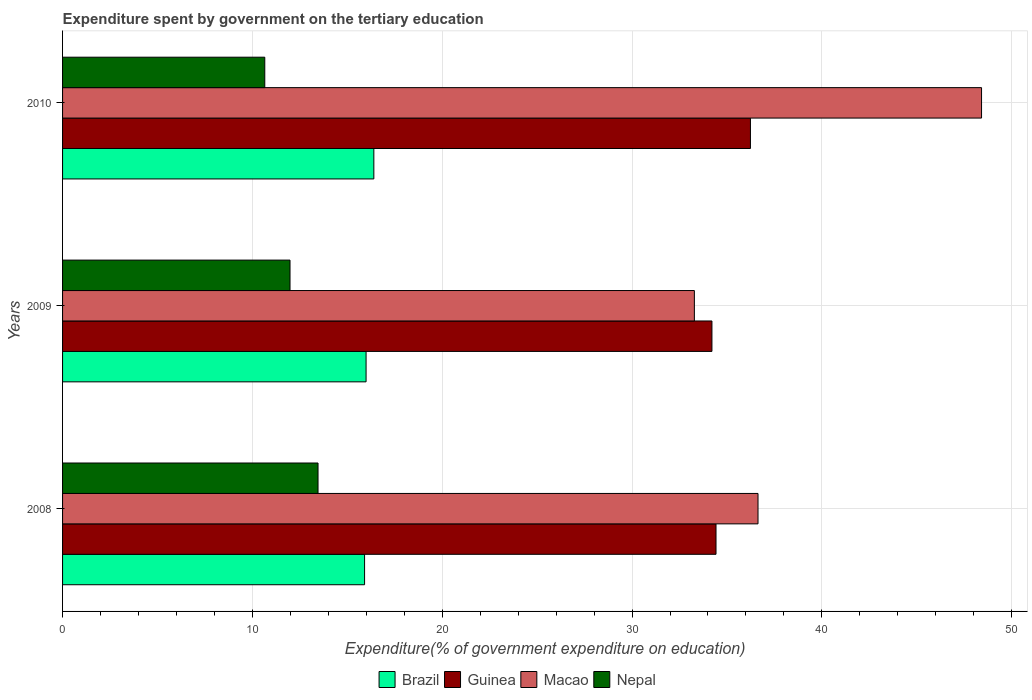How many groups of bars are there?
Provide a short and direct response. 3. Are the number of bars on each tick of the Y-axis equal?
Ensure brevity in your answer.  Yes. In how many cases, is the number of bars for a given year not equal to the number of legend labels?
Ensure brevity in your answer.  0. What is the expenditure spent by government on the tertiary education in Macao in 2010?
Offer a terse response. 48.41. Across all years, what is the maximum expenditure spent by government on the tertiary education in Nepal?
Keep it short and to the point. 13.46. Across all years, what is the minimum expenditure spent by government on the tertiary education in Nepal?
Keep it short and to the point. 10.65. In which year was the expenditure spent by government on the tertiary education in Macao maximum?
Make the answer very short. 2010. In which year was the expenditure spent by government on the tertiary education in Brazil minimum?
Keep it short and to the point. 2008. What is the total expenditure spent by government on the tertiary education in Macao in the graph?
Your answer should be very brief. 118.33. What is the difference between the expenditure spent by government on the tertiary education in Guinea in 2008 and that in 2010?
Make the answer very short. -1.81. What is the difference between the expenditure spent by government on the tertiary education in Nepal in 2010 and the expenditure spent by government on the tertiary education in Brazil in 2009?
Offer a terse response. -5.34. What is the average expenditure spent by government on the tertiary education in Brazil per year?
Your response must be concise. 16.1. In the year 2008, what is the difference between the expenditure spent by government on the tertiary education in Brazil and expenditure spent by government on the tertiary education in Guinea?
Your answer should be very brief. -18.51. In how many years, is the expenditure spent by government on the tertiary education in Guinea greater than 24 %?
Your answer should be compact. 3. What is the ratio of the expenditure spent by government on the tertiary education in Macao in 2008 to that in 2009?
Provide a succinct answer. 1.1. Is the expenditure spent by government on the tertiary education in Brazil in 2009 less than that in 2010?
Give a very brief answer. Yes. What is the difference between the highest and the second highest expenditure spent by government on the tertiary education in Macao?
Offer a terse response. 11.78. What is the difference between the highest and the lowest expenditure spent by government on the tertiary education in Brazil?
Your answer should be very brief. 0.49. In how many years, is the expenditure spent by government on the tertiary education in Macao greater than the average expenditure spent by government on the tertiary education in Macao taken over all years?
Your answer should be compact. 1. Is it the case that in every year, the sum of the expenditure spent by government on the tertiary education in Guinea and expenditure spent by government on the tertiary education in Macao is greater than the sum of expenditure spent by government on the tertiary education in Brazil and expenditure spent by government on the tertiary education in Nepal?
Ensure brevity in your answer.  No. What does the 1st bar from the top in 2009 represents?
Offer a terse response. Nepal. What does the 2nd bar from the bottom in 2009 represents?
Ensure brevity in your answer.  Guinea. What is the difference between two consecutive major ticks on the X-axis?
Ensure brevity in your answer.  10. Are the values on the major ticks of X-axis written in scientific E-notation?
Offer a terse response. No. Does the graph contain any zero values?
Keep it short and to the point. No. Where does the legend appear in the graph?
Your answer should be compact. Bottom center. What is the title of the graph?
Ensure brevity in your answer.  Expenditure spent by government on the tertiary education. Does "Portugal" appear as one of the legend labels in the graph?
Keep it short and to the point. No. What is the label or title of the X-axis?
Offer a very short reply. Expenditure(% of government expenditure on education). What is the Expenditure(% of government expenditure on education) of Brazil in 2008?
Make the answer very short. 15.91. What is the Expenditure(% of government expenditure on education) of Guinea in 2008?
Make the answer very short. 34.42. What is the Expenditure(% of government expenditure on education) in Macao in 2008?
Give a very brief answer. 36.64. What is the Expenditure(% of government expenditure on education) of Nepal in 2008?
Offer a very short reply. 13.46. What is the Expenditure(% of government expenditure on education) in Brazil in 2009?
Offer a very short reply. 15.99. What is the Expenditure(% of government expenditure on education) in Guinea in 2009?
Offer a terse response. 34.21. What is the Expenditure(% of government expenditure on education) of Macao in 2009?
Offer a very short reply. 33.28. What is the Expenditure(% of government expenditure on education) in Nepal in 2009?
Your response must be concise. 11.98. What is the Expenditure(% of government expenditure on education) in Brazil in 2010?
Ensure brevity in your answer.  16.4. What is the Expenditure(% of government expenditure on education) in Guinea in 2010?
Your answer should be compact. 36.24. What is the Expenditure(% of government expenditure on education) of Macao in 2010?
Offer a terse response. 48.41. What is the Expenditure(% of government expenditure on education) in Nepal in 2010?
Offer a very short reply. 10.65. Across all years, what is the maximum Expenditure(% of government expenditure on education) of Brazil?
Keep it short and to the point. 16.4. Across all years, what is the maximum Expenditure(% of government expenditure on education) of Guinea?
Offer a terse response. 36.24. Across all years, what is the maximum Expenditure(% of government expenditure on education) in Macao?
Your answer should be compact. 48.41. Across all years, what is the maximum Expenditure(% of government expenditure on education) in Nepal?
Your answer should be very brief. 13.46. Across all years, what is the minimum Expenditure(% of government expenditure on education) in Brazil?
Offer a very short reply. 15.91. Across all years, what is the minimum Expenditure(% of government expenditure on education) in Guinea?
Provide a succinct answer. 34.21. Across all years, what is the minimum Expenditure(% of government expenditure on education) of Macao?
Make the answer very short. 33.28. Across all years, what is the minimum Expenditure(% of government expenditure on education) in Nepal?
Give a very brief answer. 10.65. What is the total Expenditure(% of government expenditure on education) of Brazil in the graph?
Give a very brief answer. 48.3. What is the total Expenditure(% of government expenditure on education) in Guinea in the graph?
Provide a short and direct response. 104.87. What is the total Expenditure(% of government expenditure on education) in Macao in the graph?
Offer a very short reply. 118.33. What is the total Expenditure(% of government expenditure on education) in Nepal in the graph?
Keep it short and to the point. 36.09. What is the difference between the Expenditure(% of government expenditure on education) of Brazil in 2008 and that in 2009?
Offer a very short reply. -0.08. What is the difference between the Expenditure(% of government expenditure on education) in Guinea in 2008 and that in 2009?
Ensure brevity in your answer.  0.22. What is the difference between the Expenditure(% of government expenditure on education) in Macao in 2008 and that in 2009?
Keep it short and to the point. 3.35. What is the difference between the Expenditure(% of government expenditure on education) of Nepal in 2008 and that in 2009?
Offer a very short reply. 1.48. What is the difference between the Expenditure(% of government expenditure on education) of Brazil in 2008 and that in 2010?
Give a very brief answer. -0.49. What is the difference between the Expenditure(% of government expenditure on education) in Guinea in 2008 and that in 2010?
Your response must be concise. -1.81. What is the difference between the Expenditure(% of government expenditure on education) of Macao in 2008 and that in 2010?
Offer a terse response. -11.78. What is the difference between the Expenditure(% of government expenditure on education) in Nepal in 2008 and that in 2010?
Keep it short and to the point. 2.8. What is the difference between the Expenditure(% of government expenditure on education) of Brazil in 2009 and that in 2010?
Make the answer very short. -0.41. What is the difference between the Expenditure(% of government expenditure on education) in Guinea in 2009 and that in 2010?
Give a very brief answer. -2.03. What is the difference between the Expenditure(% of government expenditure on education) of Macao in 2009 and that in 2010?
Your answer should be compact. -15.13. What is the difference between the Expenditure(% of government expenditure on education) in Nepal in 2009 and that in 2010?
Ensure brevity in your answer.  1.33. What is the difference between the Expenditure(% of government expenditure on education) of Brazil in 2008 and the Expenditure(% of government expenditure on education) of Guinea in 2009?
Your answer should be very brief. -18.3. What is the difference between the Expenditure(% of government expenditure on education) in Brazil in 2008 and the Expenditure(% of government expenditure on education) in Macao in 2009?
Offer a terse response. -17.37. What is the difference between the Expenditure(% of government expenditure on education) in Brazil in 2008 and the Expenditure(% of government expenditure on education) in Nepal in 2009?
Make the answer very short. 3.93. What is the difference between the Expenditure(% of government expenditure on education) in Guinea in 2008 and the Expenditure(% of government expenditure on education) in Macao in 2009?
Make the answer very short. 1.14. What is the difference between the Expenditure(% of government expenditure on education) in Guinea in 2008 and the Expenditure(% of government expenditure on education) in Nepal in 2009?
Make the answer very short. 22.44. What is the difference between the Expenditure(% of government expenditure on education) of Macao in 2008 and the Expenditure(% of government expenditure on education) of Nepal in 2009?
Provide a short and direct response. 24.65. What is the difference between the Expenditure(% of government expenditure on education) of Brazil in 2008 and the Expenditure(% of government expenditure on education) of Guinea in 2010?
Provide a succinct answer. -20.33. What is the difference between the Expenditure(% of government expenditure on education) in Brazil in 2008 and the Expenditure(% of government expenditure on education) in Macao in 2010?
Your answer should be compact. -32.5. What is the difference between the Expenditure(% of government expenditure on education) of Brazil in 2008 and the Expenditure(% of government expenditure on education) of Nepal in 2010?
Make the answer very short. 5.26. What is the difference between the Expenditure(% of government expenditure on education) in Guinea in 2008 and the Expenditure(% of government expenditure on education) in Macao in 2010?
Your answer should be compact. -13.99. What is the difference between the Expenditure(% of government expenditure on education) in Guinea in 2008 and the Expenditure(% of government expenditure on education) in Nepal in 2010?
Make the answer very short. 23.77. What is the difference between the Expenditure(% of government expenditure on education) of Macao in 2008 and the Expenditure(% of government expenditure on education) of Nepal in 2010?
Keep it short and to the point. 25.98. What is the difference between the Expenditure(% of government expenditure on education) of Brazil in 2009 and the Expenditure(% of government expenditure on education) of Guinea in 2010?
Make the answer very short. -20.25. What is the difference between the Expenditure(% of government expenditure on education) of Brazil in 2009 and the Expenditure(% of government expenditure on education) of Macao in 2010?
Your response must be concise. -32.42. What is the difference between the Expenditure(% of government expenditure on education) of Brazil in 2009 and the Expenditure(% of government expenditure on education) of Nepal in 2010?
Offer a terse response. 5.34. What is the difference between the Expenditure(% of government expenditure on education) of Guinea in 2009 and the Expenditure(% of government expenditure on education) of Macao in 2010?
Keep it short and to the point. -14.2. What is the difference between the Expenditure(% of government expenditure on education) of Guinea in 2009 and the Expenditure(% of government expenditure on education) of Nepal in 2010?
Offer a terse response. 23.56. What is the difference between the Expenditure(% of government expenditure on education) of Macao in 2009 and the Expenditure(% of government expenditure on education) of Nepal in 2010?
Your answer should be compact. 22.63. What is the average Expenditure(% of government expenditure on education) of Brazil per year?
Your answer should be very brief. 16.1. What is the average Expenditure(% of government expenditure on education) in Guinea per year?
Give a very brief answer. 34.96. What is the average Expenditure(% of government expenditure on education) in Macao per year?
Keep it short and to the point. 39.44. What is the average Expenditure(% of government expenditure on education) of Nepal per year?
Your answer should be very brief. 12.03. In the year 2008, what is the difference between the Expenditure(% of government expenditure on education) of Brazil and Expenditure(% of government expenditure on education) of Guinea?
Ensure brevity in your answer.  -18.51. In the year 2008, what is the difference between the Expenditure(% of government expenditure on education) of Brazil and Expenditure(% of government expenditure on education) of Macao?
Your answer should be very brief. -20.73. In the year 2008, what is the difference between the Expenditure(% of government expenditure on education) in Brazil and Expenditure(% of government expenditure on education) in Nepal?
Offer a very short reply. 2.45. In the year 2008, what is the difference between the Expenditure(% of government expenditure on education) of Guinea and Expenditure(% of government expenditure on education) of Macao?
Offer a very short reply. -2.21. In the year 2008, what is the difference between the Expenditure(% of government expenditure on education) of Guinea and Expenditure(% of government expenditure on education) of Nepal?
Keep it short and to the point. 20.97. In the year 2008, what is the difference between the Expenditure(% of government expenditure on education) of Macao and Expenditure(% of government expenditure on education) of Nepal?
Your answer should be compact. 23.18. In the year 2009, what is the difference between the Expenditure(% of government expenditure on education) of Brazil and Expenditure(% of government expenditure on education) of Guinea?
Give a very brief answer. -18.22. In the year 2009, what is the difference between the Expenditure(% of government expenditure on education) in Brazil and Expenditure(% of government expenditure on education) in Macao?
Provide a short and direct response. -17.29. In the year 2009, what is the difference between the Expenditure(% of government expenditure on education) of Brazil and Expenditure(% of government expenditure on education) of Nepal?
Provide a short and direct response. 4.01. In the year 2009, what is the difference between the Expenditure(% of government expenditure on education) in Guinea and Expenditure(% of government expenditure on education) in Macao?
Offer a terse response. 0.93. In the year 2009, what is the difference between the Expenditure(% of government expenditure on education) of Guinea and Expenditure(% of government expenditure on education) of Nepal?
Ensure brevity in your answer.  22.23. In the year 2009, what is the difference between the Expenditure(% of government expenditure on education) of Macao and Expenditure(% of government expenditure on education) of Nepal?
Provide a short and direct response. 21.3. In the year 2010, what is the difference between the Expenditure(% of government expenditure on education) in Brazil and Expenditure(% of government expenditure on education) in Guinea?
Give a very brief answer. -19.84. In the year 2010, what is the difference between the Expenditure(% of government expenditure on education) in Brazil and Expenditure(% of government expenditure on education) in Macao?
Your response must be concise. -32.01. In the year 2010, what is the difference between the Expenditure(% of government expenditure on education) in Brazil and Expenditure(% of government expenditure on education) in Nepal?
Offer a terse response. 5.75. In the year 2010, what is the difference between the Expenditure(% of government expenditure on education) of Guinea and Expenditure(% of government expenditure on education) of Macao?
Give a very brief answer. -12.17. In the year 2010, what is the difference between the Expenditure(% of government expenditure on education) of Guinea and Expenditure(% of government expenditure on education) of Nepal?
Make the answer very short. 25.58. In the year 2010, what is the difference between the Expenditure(% of government expenditure on education) of Macao and Expenditure(% of government expenditure on education) of Nepal?
Your answer should be compact. 37.76. What is the ratio of the Expenditure(% of government expenditure on education) of Brazil in 2008 to that in 2009?
Your answer should be compact. 1. What is the ratio of the Expenditure(% of government expenditure on education) in Macao in 2008 to that in 2009?
Your answer should be very brief. 1.1. What is the ratio of the Expenditure(% of government expenditure on education) in Nepal in 2008 to that in 2009?
Your answer should be compact. 1.12. What is the ratio of the Expenditure(% of government expenditure on education) in Brazil in 2008 to that in 2010?
Your answer should be compact. 0.97. What is the ratio of the Expenditure(% of government expenditure on education) in Guinea in 2008 to that in 2010?
Provide a succinct answer. 0.95. What is the ratio of the Expenditure(% of government expenditure on education) of Macao in 2008 to that in 2010?
Your answer should be very brief. 0.76. What is the ratio of the Expenditure(% of government expenditure on education) in Nepal in 2008 to that in 2010?
Make the answer very short. 1.26. What is the ratio of the Expenditure(% of government expenditure on education) of Brazil in 2009 to that in 2010?
Provide a short and direct response. 0.97. What is the ratio of the Expenditure(% of government expenditure on education) of Guinea in 2009 to that in 2010?
Offer a terse response. 0.94. What is the ratio of the Expenditure(% of government expenditure on education) in Macao in 2009 to that in 2010?
Provide a succinct answer. 0.69. What is the ratio of the Expenditure(% of government expenditure on education) of Nepal in 2009 to that in 2010?
Your answer should be compact. 1.12. What is the difference between the highest and the second highest Expenditure(% of government expenditure on education) of Brazil?
Keep it short and to the point. 0.41. What is the difference between the highest and the second highest Expenditure(% of government expenditure on education) in Guinea?
Offer a terse response. 1.81. What is the difference between the highest and the second highest Expenditure(% of government expenditure on education) in Macao?
Ensure brevity in your answer.  11.78. What is the difference between the highest and the second highest Expenditure(% of government expenditure on education) in Nepal?
Your answer should be compact. 1.48. What is the difference between the highest and the lowest Expenditure(% of government expenditure on education) in Brazil?
Give a very brief answer. 0.49. What is the difference between the highest and the lowest Expenditure(% of government expenditure on education) in Guinea?
Ensure brevity in your answer.  2.03. What is the difference between the highest and the lowest Expenditure(% of government expenditure on education) of Macao?
Keep it short and to the point. 15.13. What is the difference between the highest and the lowest Expenditure(% of government expenditure on education) in Nepal?
Make the answer very short. 2.8. 